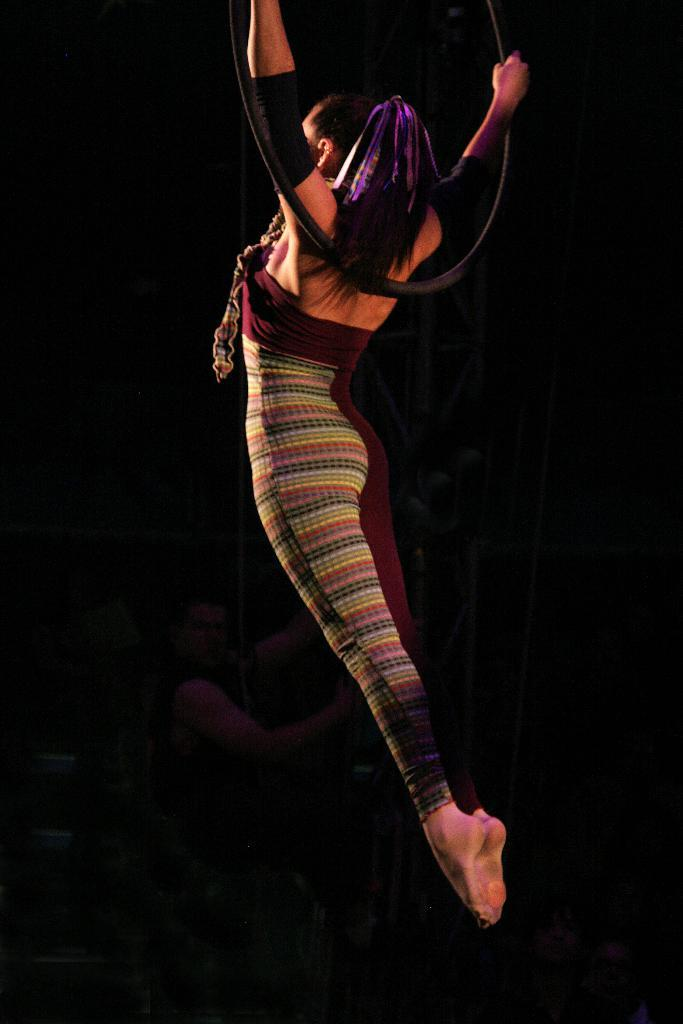Who is the main subject in the image? There is a woman in the image. What is the woman doing in the image? The woman is performing. What object is the woman holding in the image? The woman is holding a round and black color object. What type of house is depicted in the image? There is no house depicted in the image; it features a woman performing while holding a round and black color object. 